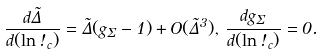<formula> <loc_0><loc_0><loc_500><loc_500>\frac { d \tilde { \Delta } } { d ( \ln \omega _ { c } ) } = \tilde { \Delta } ( g _ { \Sigma } - 1 ) + O ( \tilde { \Delta } ^ { 3 } ) , \, \frac { d g _ { \Sigma } } { d ( \ln \omega _ { c } ) } = 0 .</formula> 